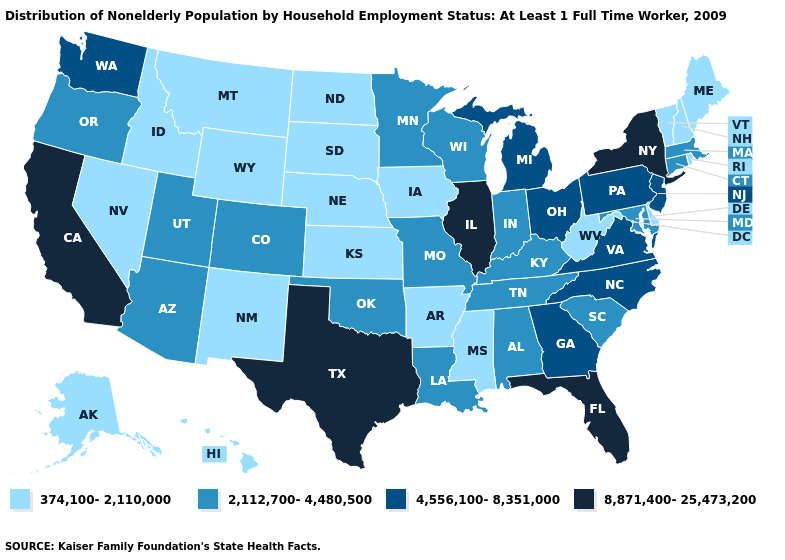Is the legend a continuous bar?
Short answer required. No. Which states have the lowest value in the MidWest?
Keep it brief. Iowa, Kansas, Nebraska, North Dakota, South Dakota. What is the value of New Hampshire?
Short answer required. 374,100-2,110,000. How many symbols are there in the legend?
Write a very short answer. 4. What is the value of Nebraska?
Give a very brief answer. 374,100-2,110,000. Name the states that have a value in the range 8,871,400-25,473,200?
Be succinct. California, Florida, Illinois, New York, Texas. Name the states that have a value in the range 374,100-2,110,000?
Be succinct. Alaska, Arkansas, Delaware, Hawaii, Idaho, Iowa, Kansas, Maine, Mississippi, Montana, Nebraska, Nevada, New Hampshire, New Mexico, North Dakota, Rhode Island, South Dakota, Vermont, West Virginia, Wyoming. What is the value of North Dakota?
Quick response, please. 374,100-2,110,000. Does Arizona have the highest value in the USA?
Answer briefly. No. Is the legend a continuous bar?
Quick response, please. No. What is the value of Illinois?
Be succinct. 8,871,400-25,473,200. Among the states that border New York , which have the highest value?
Quick response, please. New Jersey, Pennsylvania. Among the states that border West Virginia , which have the highest value?
Concise answer only. Ohio, Pennsylvania, Virginia. Among the states that border Nebraska , does Kansas have the lowest value?
Keep it brief. Yes. 